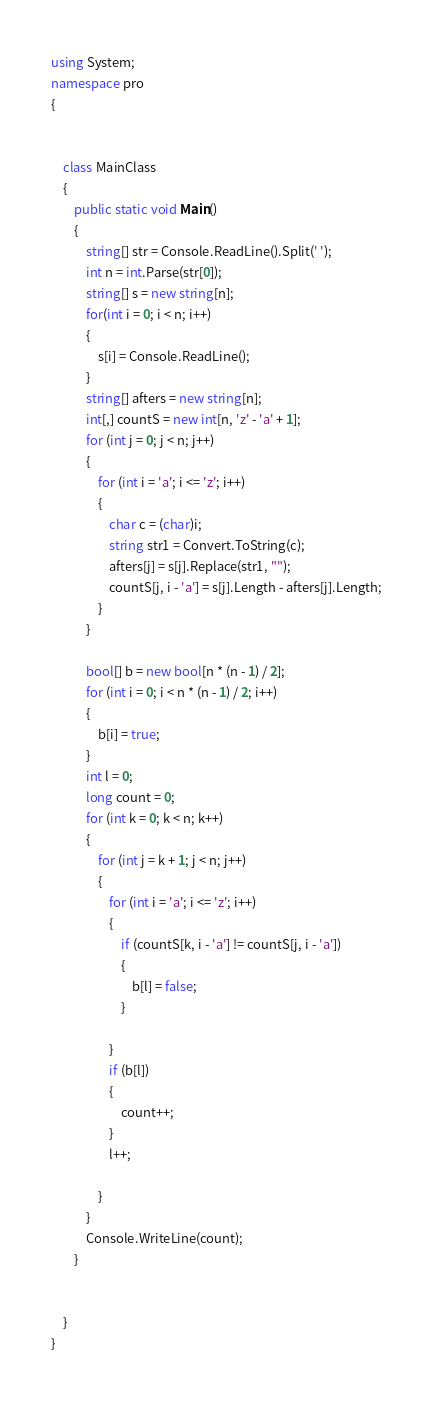Convert code to text. <code><loc_0><loc_0><loc_500><loc_500><_C#_>using System;
namespace pro
{


    class MainClass
    {
        public static void Main()
        {
            string[] str = Console.ReadLine().Split(' ');
            int n = int.Parse(str[0]);
            string[] s = new string[n];
            for(int i = 0; i < n; i++)
            {
                s[i] = Console.ReadLine();
            }
            string[] afters = new string[n];
            int[,] countS = new int[n, 'z' - 'a' + 1];
            for (int j = 0; j < n; j++)
            {
                for (int i = 'a'; i <= 'z'; i++)
                {
                    char c = (char)i;
                    string str1 = Convert.ToString(c);
                    afters[j] = s[j].Replace(str1, "");
                    countS[j, i - 'a'] = s[j].Length - afters[j].Length;
                }
            }

            bool[] b = new bool[n * (n - 1) / 2];
            for (int i = 0; i < n * (n - 1) / 2; i++)
            {
                b[i] = true;
            }
            int l = 0;
            long count = 0;
            for (int k = 0; k < n; k++)
            {
                for (int j = k + 1; j < n; j++)
                {
                    for (int i = 'a'; i <= 'z'; i++)
                    {
                        if (countS[k, i - 'a'] != countS[j, i - 'a'])
                        {
                            b[l] = false;
                        }

                    }
                    if (b[l])
                    {
                        count++;
                    }
                    l++;

                }
            }
            Console.WriteLine(count);
        }


    }
}</code> 